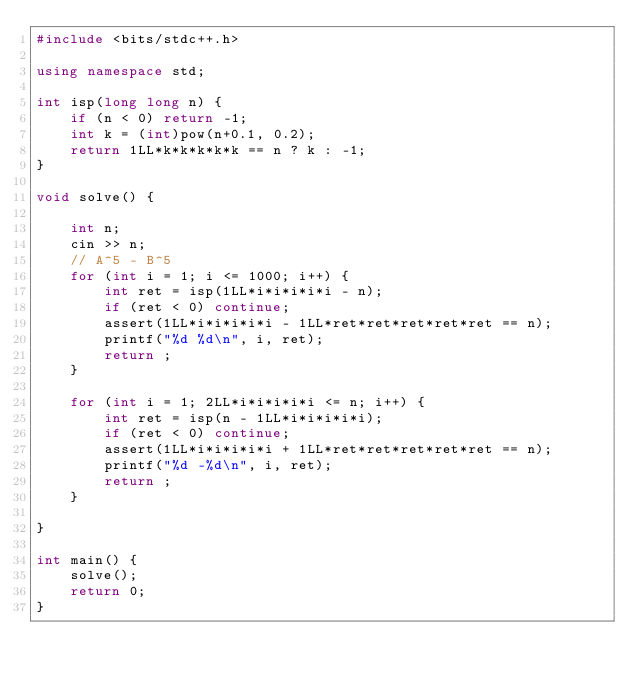<code> <loc_0><loc_0><loc_500><loc_500><_C++_>#include <bits/stdc++.h>

using namespace std;

int isp(long long n) {
    if (n < 0) return -1;
    int k = (int)pow(n+0.1, 0.2);
    return 1LL*k*k*k*k*k == n ? k : -1;
}

void solve() {

    int n;
    cin >> n;
    // A^5 - B^5
    for (int i = 1; i <= 1000; i++) {
        int ret = isp(1LL*i*i*i*i*i - n);
        if (ret < 0) continue;
        assert(1LL*i*i*i*i*i - 1LL*ret*ret*ret*ret*ret == n);
        printf("%d %d\n", i, ret);
        return ;
    }

    for (int i = 1; 2LL*i*i*i*i*i <= n; i++) {
        int ret = isp(n - 1LL*i*i*i*i*i);
        if (ret < 0) continue;
        assert(1LL*i*i*i*i*i + 1LL*ret*ret*ret*ret*ret == n);
        printf("%d -%d\n", i, ret);
        return ;
    }

}

int main() {
    solve();
    return 0;
}</code> 